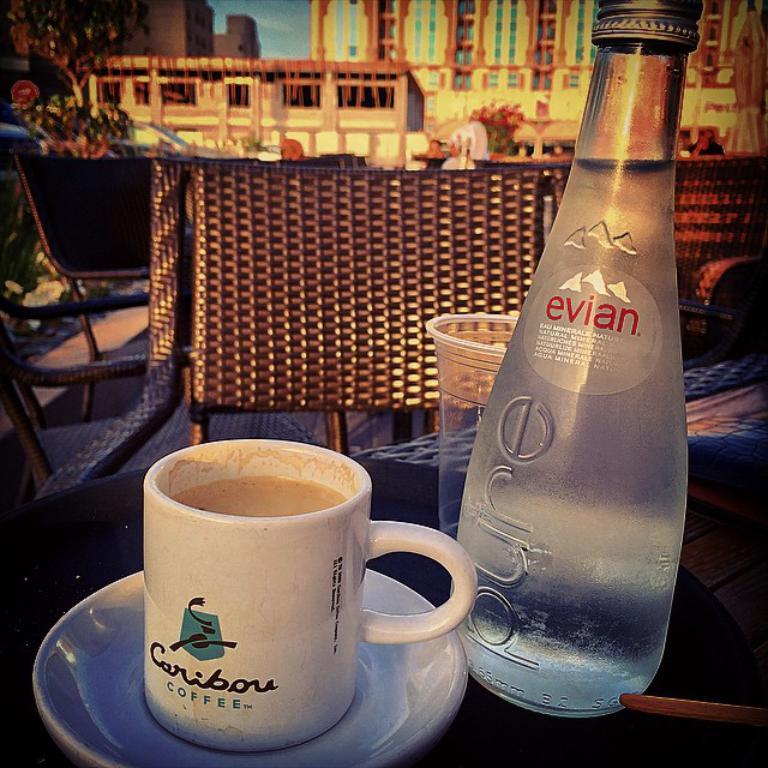Please provide a concise description of this image. in the center we can see coffee cup,water bottle on the table. And coming to the background we can see the chair,plant,building and sky. 